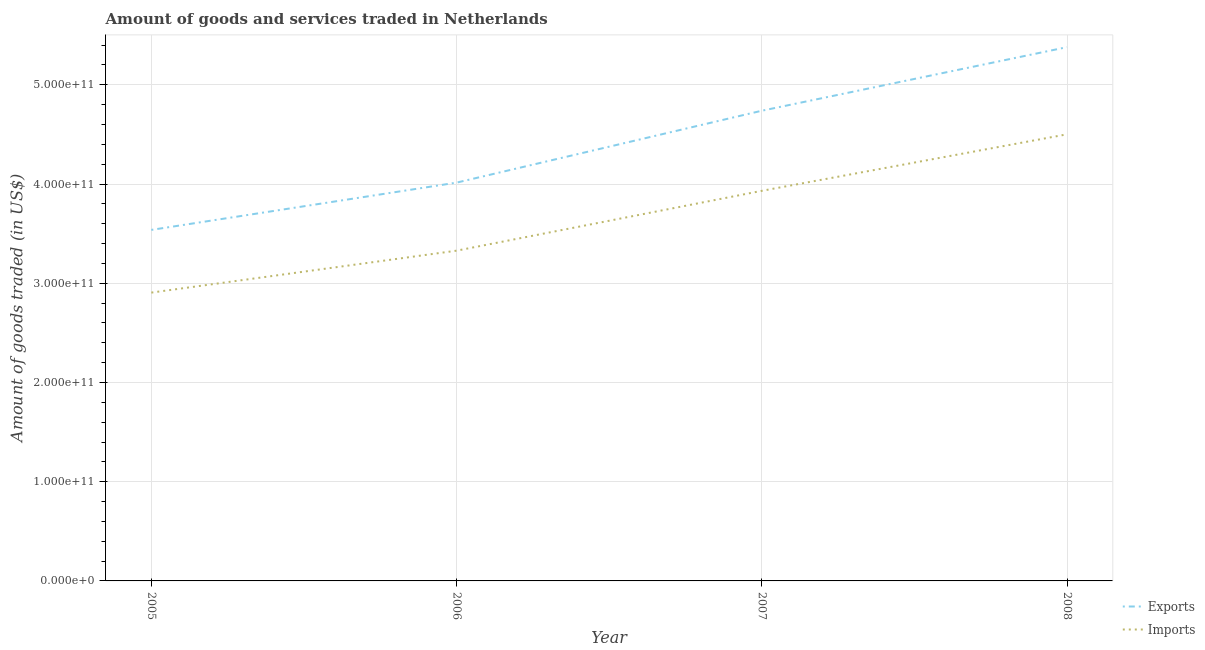Does the line corresponding to amount of goods exported intersect with the line corresponding to amount of goods imported?
Ensure brevity in your answer.  No. What is the amount of goods imported in 2005?
Give a very brief answer. 2.91e+11. Across all years, what is the maximum amount of goods exported?
Give a very brief answer. 5.38e+11. Across all years, what is the minimum amount of goods exported?
Offer a terse response. 3.54e+11. In which year was the amount of goods imported minimum?
Provide a short and direct response. 2005. What is the total amount of goods imported in the graph?
Keep it short and to the point. 1.47e+12. What is the difference between the amount of goods imported in 2007 and that in 2008?
Make the answer very short. -5.70e+1. What is the difference between the amount of goods exported in 2006 and the amount of goods imported in 2008?
Make the answer very short. -4.87e+1. What is the average amount of goods imported per year?
Provide a short and direct response. 3.67e+11. In the year 2007, what is the difference between the amount of goods imported and amount of goods exported?
Offer a terse response. -8.07e+1. What is the ratio of the amount of goods imported in 2006 to that in 2007?
Provide a succinct answer. 0.85. Is the amount of goods imported in 2006 less than that in 2007?
Provide a succinct answer. Yes. What is the difference between the highest and the second highest amount of goods exported?
Provide a succinct answer. 6.41e+1. What is the difference between the highest and the lowest amount of goods exported?
Your answer should be very brief. 1.84e+11. In how many years, is the amount of goods imported greater than the average amount of goods imported taken over all years?
Your response must be concise. 2. Is the sum of the amount of goods imported in 2007 and 2008 greater than the maximum amount of goods exported across all years?
Keep it short and to the point. Yes. Does the amount of goods exported monotonically increase over the years?
Offer a very short reply. Yes. Is the amount of goods imported strictly less than the amount of goods exported over the years?
Offer a terse response. Yes. How many years are there in the graph?
Your response must be concise. 4. What is the difference between two consecutive major ticks on the Y-axis?
Your answer should be very brief. 1.00e+11. Are the values on the major ticks of Y-axis written in scientific E-notation?
Give a very brief answer. Yes. Does the graph contain any zero values?
Provide a short and direct response. No. How many legend labels are there?
Provide a short and direct response. 2. How are the legend labels stacked?
Keep it short and to the point. Vertical. What is the title of the graph?
Keep it short and to the point. Amount of goods and services traded in Netherlands. What is the label or title of the Y-axis?
Your response must be concise. Amount of goods traded (in US$). What is the Amount of goods traded (in US$) of Exports in 2005?
Offer a terse response. 3.54e+11. What is the Amount of goods traded (in US$) in Imports in 2005?
Make the answer very short. 2.91e+11. What is the Amount of goods traded (in US$) of Exports in 2006?
Ensure brevity in your answer.  4.01e+11. What is the Amount of goods traded (in US$) of Imports in 2006?
Offer a terse response. 3.33e+11. What is the Amount of goods traded (in US$) of Exports in 2007?
Your response must be concise. 4.74e+11. What is the Amount of goods traded (in US$) in Imports in 2007?
Ensure brevity in your answer.  3.93e+11. What is the Amount of goods traded (in US$) in Exports in 2008?
Your answer should be very brief. 5.38e+11. What is the Amount of goods traded (in US$) in Imports in 2008?
Give a very brief answer. 4.50e+11. Across all years, what is the maximum Amount of goods traded (in US$) in Exports?
Keep it short and to the point. 5.38e+11. Across all years, what is the maximum Amount of goods traded (in US$) in Imports?
Your response must be concise. 4.50e+11. Across all years, what is the minimum Amount of goods traded (in US$) of Exports?
Your response must be concise. 3.54e+11. Across all years, what is the minimum Amount of goods traded (in US$) in Imports?
Give a very brief answer. 2.91e+11. What is the total Amount of goods traded (in US$) of Exports in the graph?
Offer a very short reply. 1.77e+12. What is the total Amount of goods traded (in US$) in Imports in the graph?
Keep it short and to the point. 1.47e+12. What is the difference between the Amount of goods traded (in US$) in Exports in 2005 and that in 2006?
Make the answer very short. -4.76e+1. What is the difference between the Amount of goods traded (in US$) of Imports in 2005 and that in 2006?
Give a very brief answer. -4.23e+1. What is the difference between the Amount of goods traded (in US$) of Exports in 2005 and that in 2007?
Give a very brief answer. -1.20e+11. What is the difference between the Amount of goods traded (in US$) of Imports in 2005 and that in 2007?
Offer a terse response. -1.03e+11. What is the difference between the Amount of goods traded (in US$) in Exports in 2005 and that in 2008?
Provide a short and direct response. -1.84e+11. What is the difference between the Amount of goods traded (in US$) in Imports in 2005 and that in 2008?
Provide a succinct answer. -1.60e+11. What is the difference between the Amount of goods traded (in US$) in Exports in 2006 and that in 2007?
Give a very brief answer. -7.25e+1. What is the difference between the Amount of goods traded (in US$) of Imports in 2006 and that in 2007?
Provide a succinct answer. -6.03e+1. What is the difference between the Amount of goods traded (in US$) of Exports in 2006 and that in 2008?
Make the answer very short. -1.37e+11. What is the difference between the Amount of goods traded (in US$) in Imports in 2006 and that in 2008?
Ensure brevity in your answer.  -1.17e+11. What is the difference between the Amount of goods traded (in US$) in Exports in 2007 and that in 2008?
Offer a very short reply. -6.41e+1. What is the difference between the Amount of goods traded (in US$) of Imports in 2007 and that in 2008?
Give a very brief answer. -5.70e+1. What is the difference between the Amount of goods traded (in US$) of Exports in 2005 and the Amount of goods traded (in US$) of Imports in 2006?
Keep it short and to the point. 2.09e+1. What is the difference between the Amount of goods traded (in US$) of Exports in 2005 and the Amount of goods traded (in US$) of Imports in 2007?
Offer a very short reply. -3.94e+1. What is the difference between the Amount of goods traded (in US$) of Exports in 2005 and the Amount of goods traded (in US$) of Imports in 2008?
Offer a very short reply. -9.63e+1. What is the difference between the Amount of goods traded (in US$) in Exports in 2006 and the Amount of goods traded (in US$) in Imports in 2007?
Provide a short and direct response. 8.26e+09. What is the difference between the Amount of goods traded (in US$) in Exports in 2006 and the Amount of goods traded (in US$) in Imports in 2008?
Give a very brief answer. -4.87e+1. What is the difference between the Amount of goods traded (in US$) of Exports in 2007 and the Amount of goods traded (in US$) of Imports in 2008?
Offer a very short reply. 2.38e+1. What is the average Amount of goods traded (in US$) in Exports per year?
Keep it short and to the point. 4.42e+11. What is the average Amount of goods traded (in US$) of Imports per year?
Give a very brief answer. 3.67e+11. In the year 2005, what is the difference between the Amount of goods traded (in US$) of Exports and Amount of goods traded (in US$) of Imports?
Offer a very short reply. 6.32e+1. In the year 2006, what is the difference between the Amount of goods traded (in US$) in Exports and Amount of goods traded (in US$) in Imports?
Provide a short and direct response. 6.86e+1. In the year 2007, what is the difference between the Amount of goods traded (in US$) in Exports and Amount of goods traded (in US$) in Imports?
Your answer should be compact. 8.07e+1. In the year 2008, what is the difference between the Amount of goods traded (in US$) of Exports and Amount of goods traded (in US$) of Imports?
Provide a short and direct response. 8.78e+1. What is the ratio of the Amount of goods traded (in US$) of Exports in 2005 to that in 2006?
Offer a very short reply. 0.88. What is the ratio of the Amount of goods traded (in US$) of Imports in 2005 to that in 2006?
Your response must be concise. 0.87. What is the ratio of the Amount of goods traded (in US$) in Exports in 2005 to that in 2007?
Make the answer very short. 0.75. What is the ratio of the Amount of goods traded (in US$) in Imports in 2005 to that in 2007?
Your response must be concise. 0.74. What is the ratio of the Amount of goods traded (in US$) in Exports in 2005 to that in 2008?
Offer a terse response. 0.66. What is the ratio of the Amount of goods traded (in US$) of Imports in 2005 to that in 2008?
Offer a terse response. 0.65. What is the ratio of the Amount of goods traded (in US$) of Exports in 2006 to that in 2007?
Provide a short and direct response. 0.85. What is the ratio of the Amount of goods traded (in US$) of Imports in 2006 to that in 2007?
Ensure brevity in your answer.  0.85. What is the ratio of the Amount of goods traded (in US$) in Exports in 2006 to that in 2008?
Keep it short and to the point. 0.75. What is the ratio of the Amount of goods traded (in US$) of Imports in 2006 to that in 2008?
Your answer should be compact. 0.74. What is the ratio of the Amount of goods traded (in US$) of Exports in 2007 to that in 2008?
Your answer should be compact. 0.88. What is the ratio of the Amount of goods traded (in US$) of Imports in 2007 to that in 2008?
Your response must be concise. 0.87. What is the difference between the highest and the second highest Amount of goods traded (in US$) of Exports?
Keep it short and to the point. 6.41e+1. What is the difference between the highest and the second highest Amount of goods traded (in US$) of Imports?
Your answer should be very brief. 5.70e+1. What is the difference between the highest and the lowest Amount of goods traded (in US$) of Exports?
Offer a terse response. 1.84e+11. What is the difference between the highest and the lowest Amount of goods traded (in US$) of Imports?
Make the answer very short. 1.60e+11. 